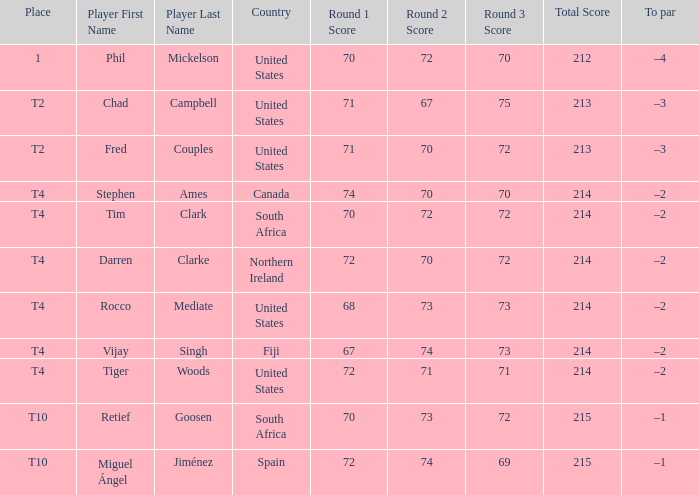What was the result for spain? 72-74-69=215. 